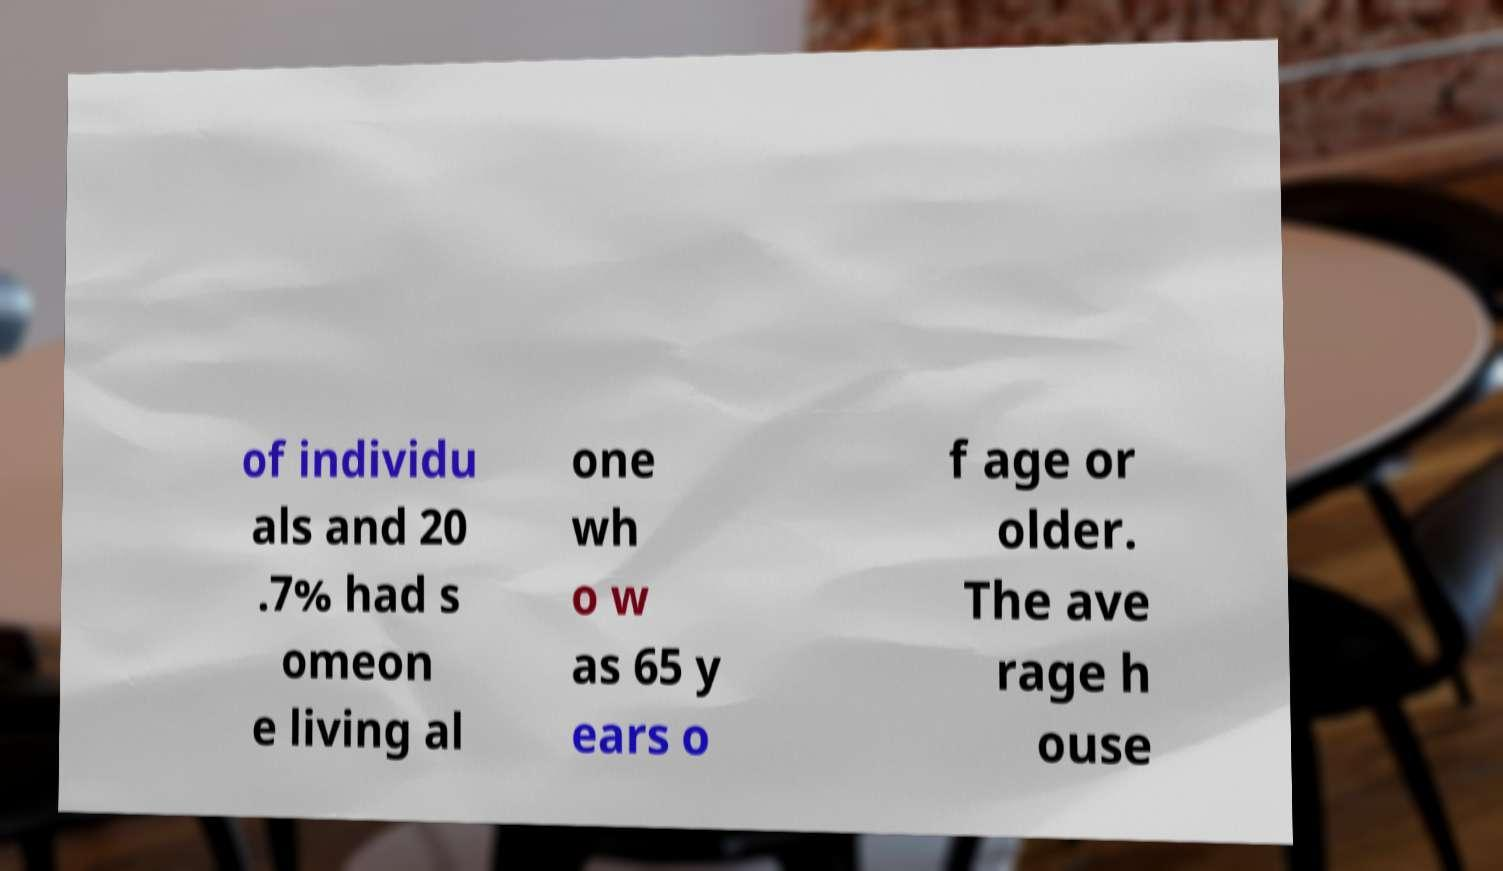Could you assist in decoding the text presented in this image and type it out clearly? of individu als and 20 .7% had s omeon e living al one wh o w as 65 y ears o f age or older. The ave rage h ouse 